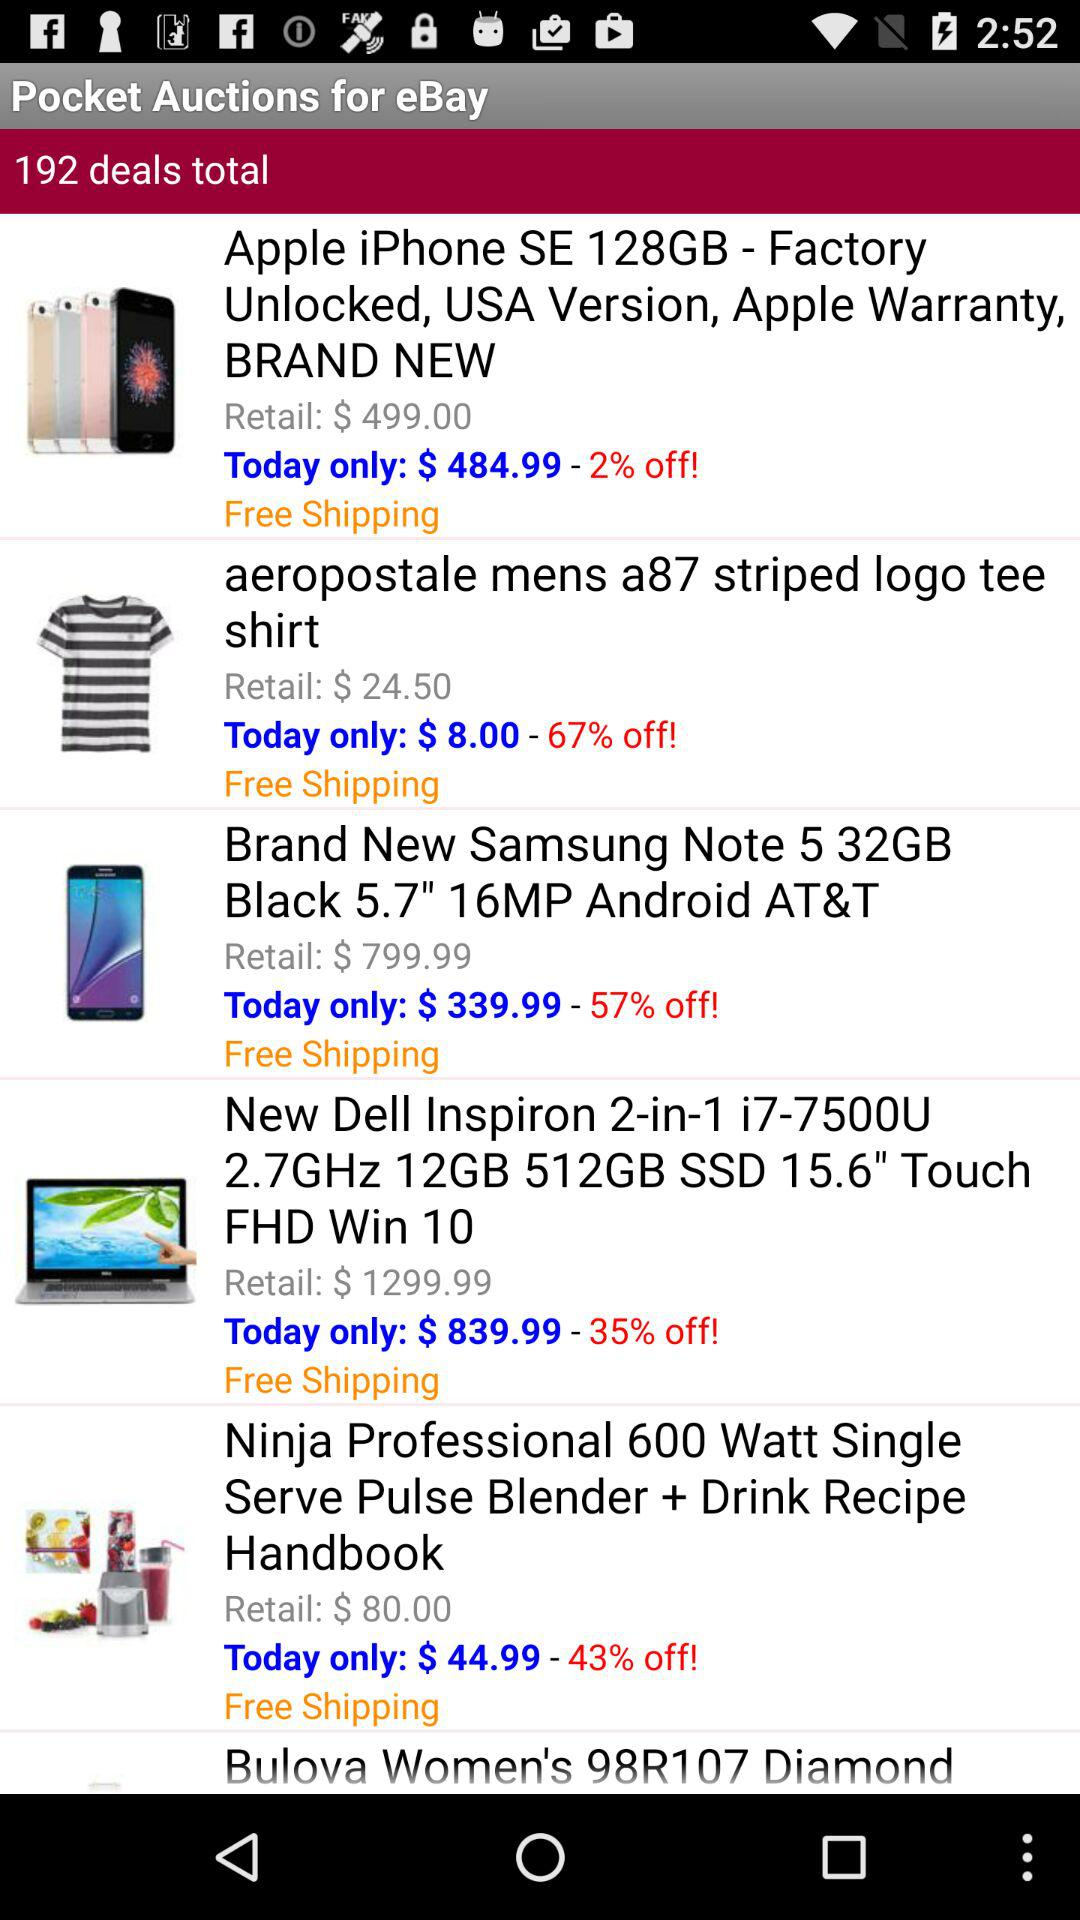What is the shipping charge for the "Brand New Samsung Note 5 32GB Black 5.7" 16 MP Android AT&T"?
Answer the question using a single word or phrase. Shipping is free. 